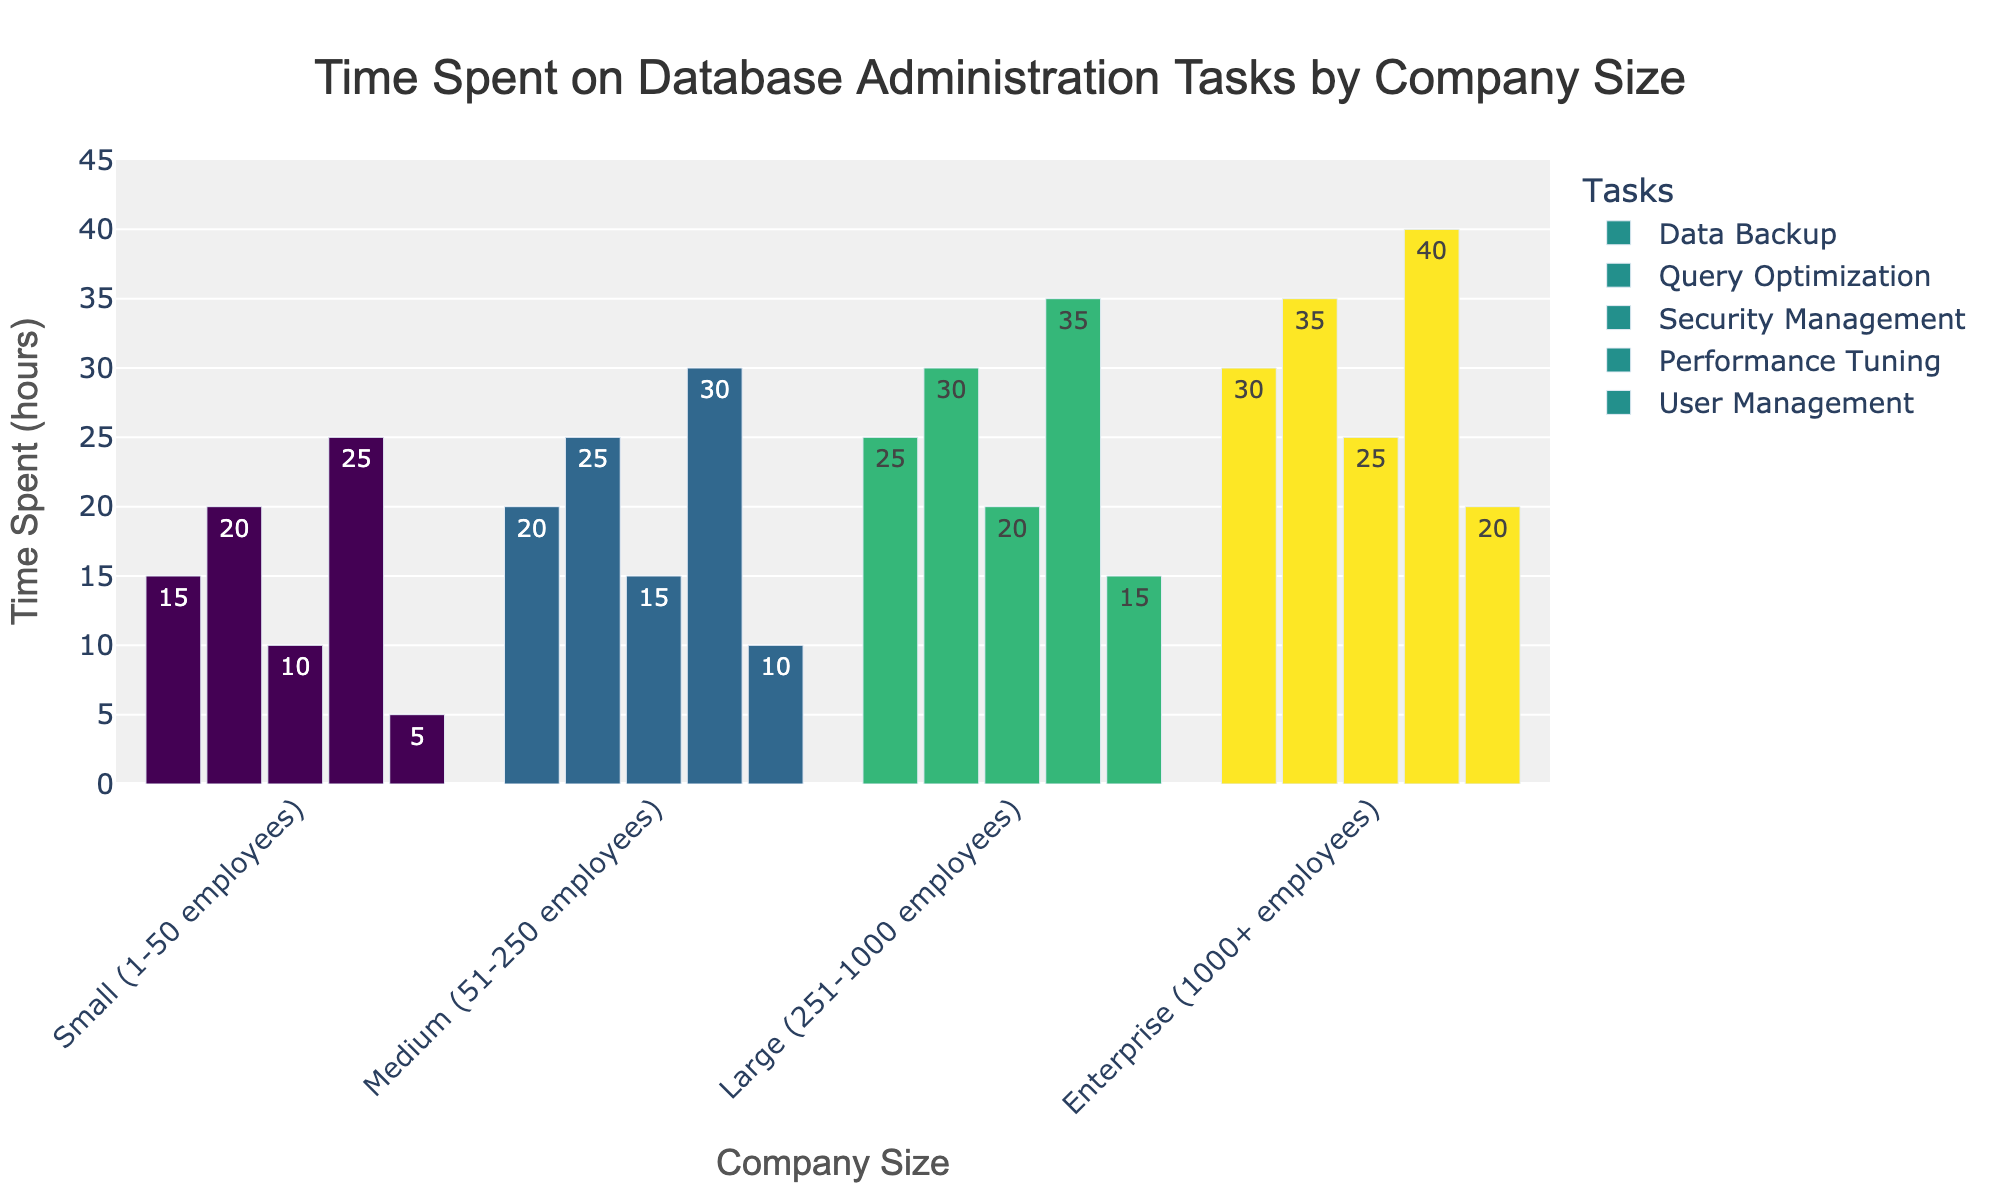What's the total time spent on user management by all company sizes? Add up the time spent on user management from each company size: 5 (small) + 10 (medium) + 15 (large) + 20 (enterprise) = 50 hours
Answer: 50 hours Which task takes the most time in enterprise-sized companies? Look at the bars for enterprise-sized companies and identify the task with the highest bar. Security management takes 40 hours, which is the highest.
Answer: Security management How much more time do medium-sized companies spend on performance tuning compared to small-sized companies? Subtract the time medium-sized companies spend on performance tuning from the time small-sized companies spend on performance tuning: 30 - 25 = 5 hours
Answer: 5 hours Which company size spends the least time on data backup? Compare the bars for data backup across all company sizes. Small-sized companies spend the least time, which is 15 hours.
Answer: Small (1-50 employees) Which task is the most consistent in terms of time spent across different company sizes? Compare the bars of each task across different company sizes for the smallest variation in height. Data backup shows the most even distribution from 15 (small) to 30 (enterprise)
Answer: Data Backup What is the average time spent on query optimization by all company sizes? Add up the time spent on query optimization by all company sizes and divide by the number of company sizes: (20+25+30+35)/4 = 27.5 hours
Answer: 27.5 hours How much time does a large company spend on management tasks (user management + security management)? Sum up the times spent on user management and security management for large companies: 15 + 20 = 35 hours
Answer: 35 hours Do small companies spend more or less time on data backup than performance tuning? Compare the bars for data backup and performance tuning for small companies. Data backup is 15 hours whereas performance tuning is 25 hours.
Answer: Less What is the range of time spent on query optimization across different company sizes? Calculate the difference between the maximum and the minimum times spent on query optimization: 35 - 20 = 15 hours
Answer: 15 hours Which company size spends the most time on security management? Compare the bars for security management across all company sizes. Enterprise companies spend the most time, which is 25 hours.
Answer: Enterprise (1000+ employees) 